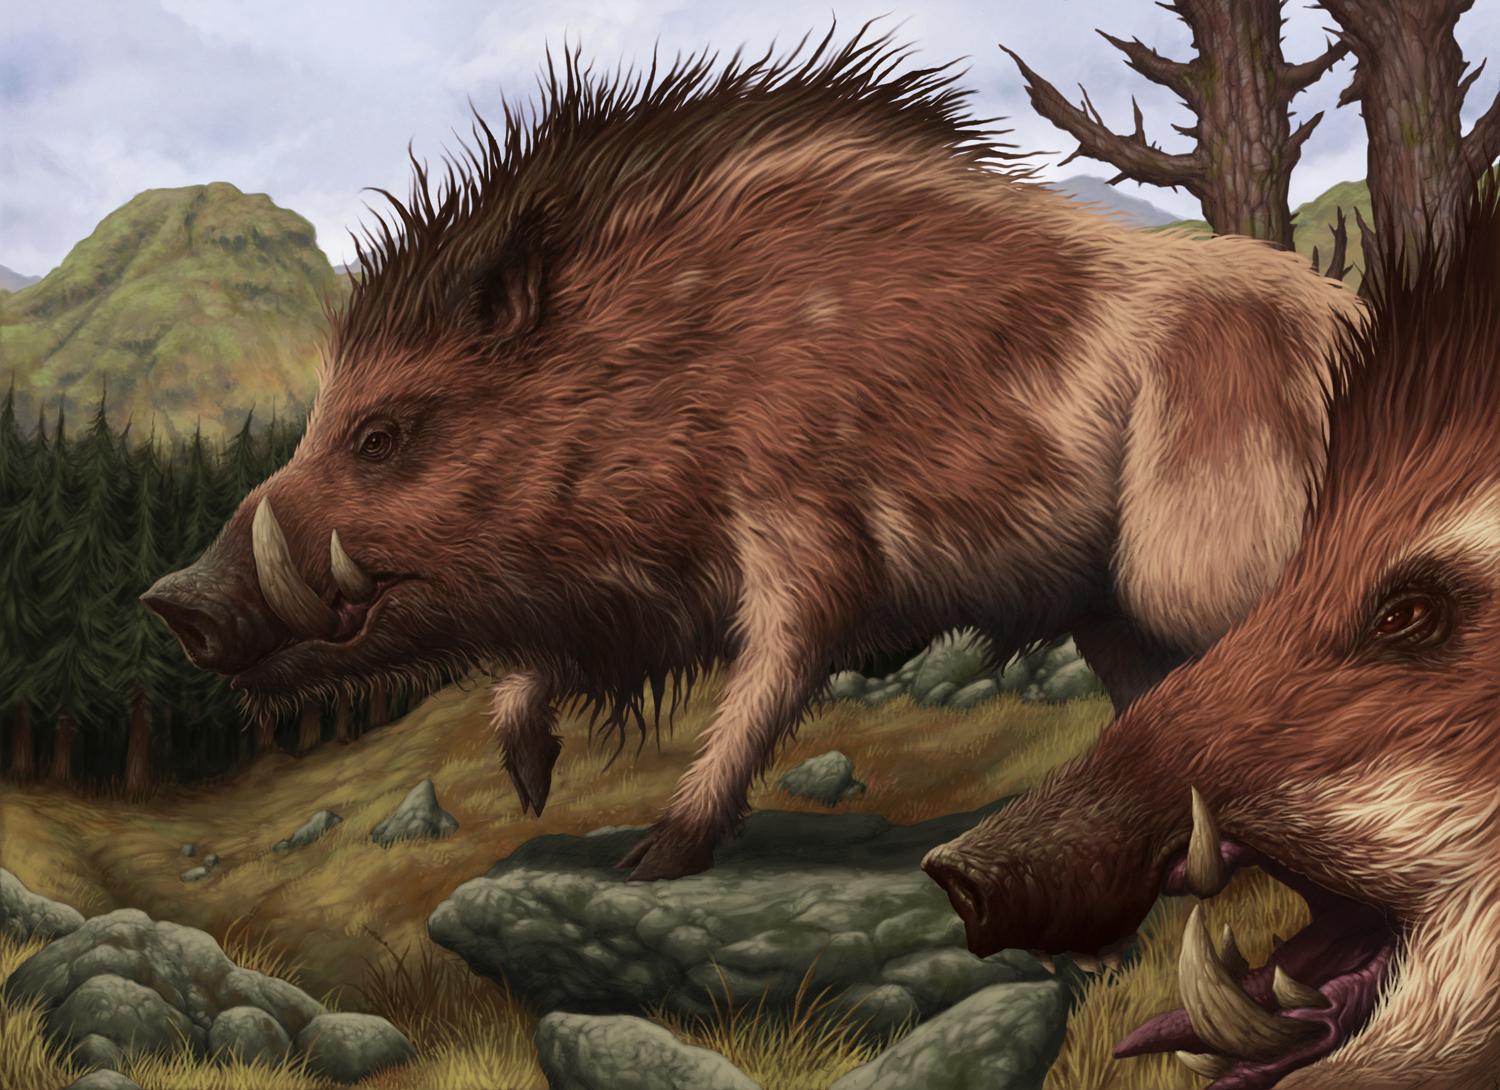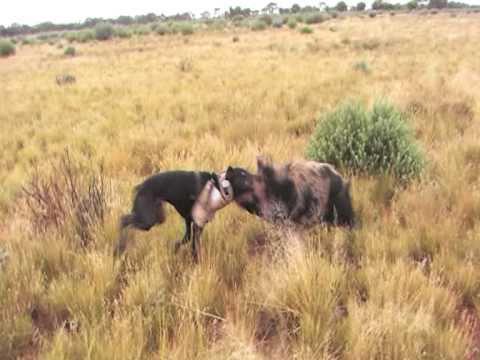The first image is the image on the left, the second image is the image on the right. Examine the images to the left and right. Is the description "There's more than one pig in each picture of the pair" accurate? Answer yes or no. No. 